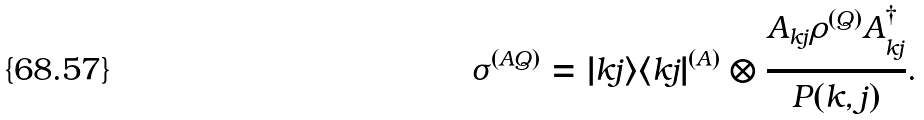<formula> <loc_0><loc_0><loc_500><loc_500>\sigma ^ { ( A Q ) } = | k j \rangle \langle k j | ^ { ( A ) } \otimes \frac { A _ { k j } \rho ^ { ( Q ) } A _ { k j } ^ { \dagger } } { P ( k , j ) } .</formula> 